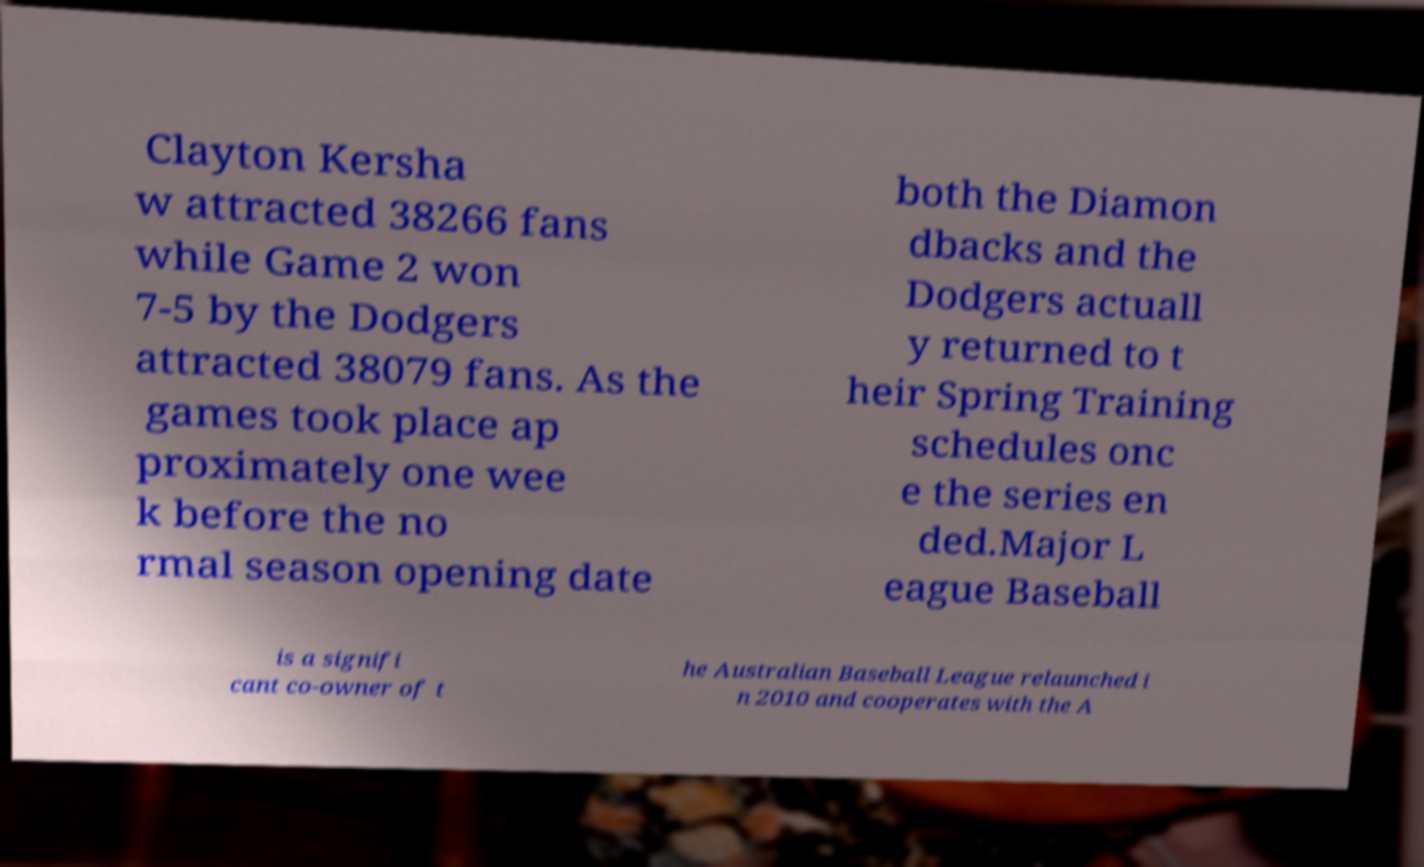What messages or text are displayed in this image? I need them in a readable, typed format. Clayton Kersha w attracted 38266 fans while Game 2 won 7-5 by the Dodgers attracted 38079 fans. As the games took place ap proximately one wee k before the no rmal season opening date both the Diamon dbacks and the Dodgers actuall y returned to t heir Spring Training schedules onc e the series en ded.Major L eague Baseball is a signifi cant co-owner of t he Australian Baseball League relaunched i n 2010 and cooperates with the A 